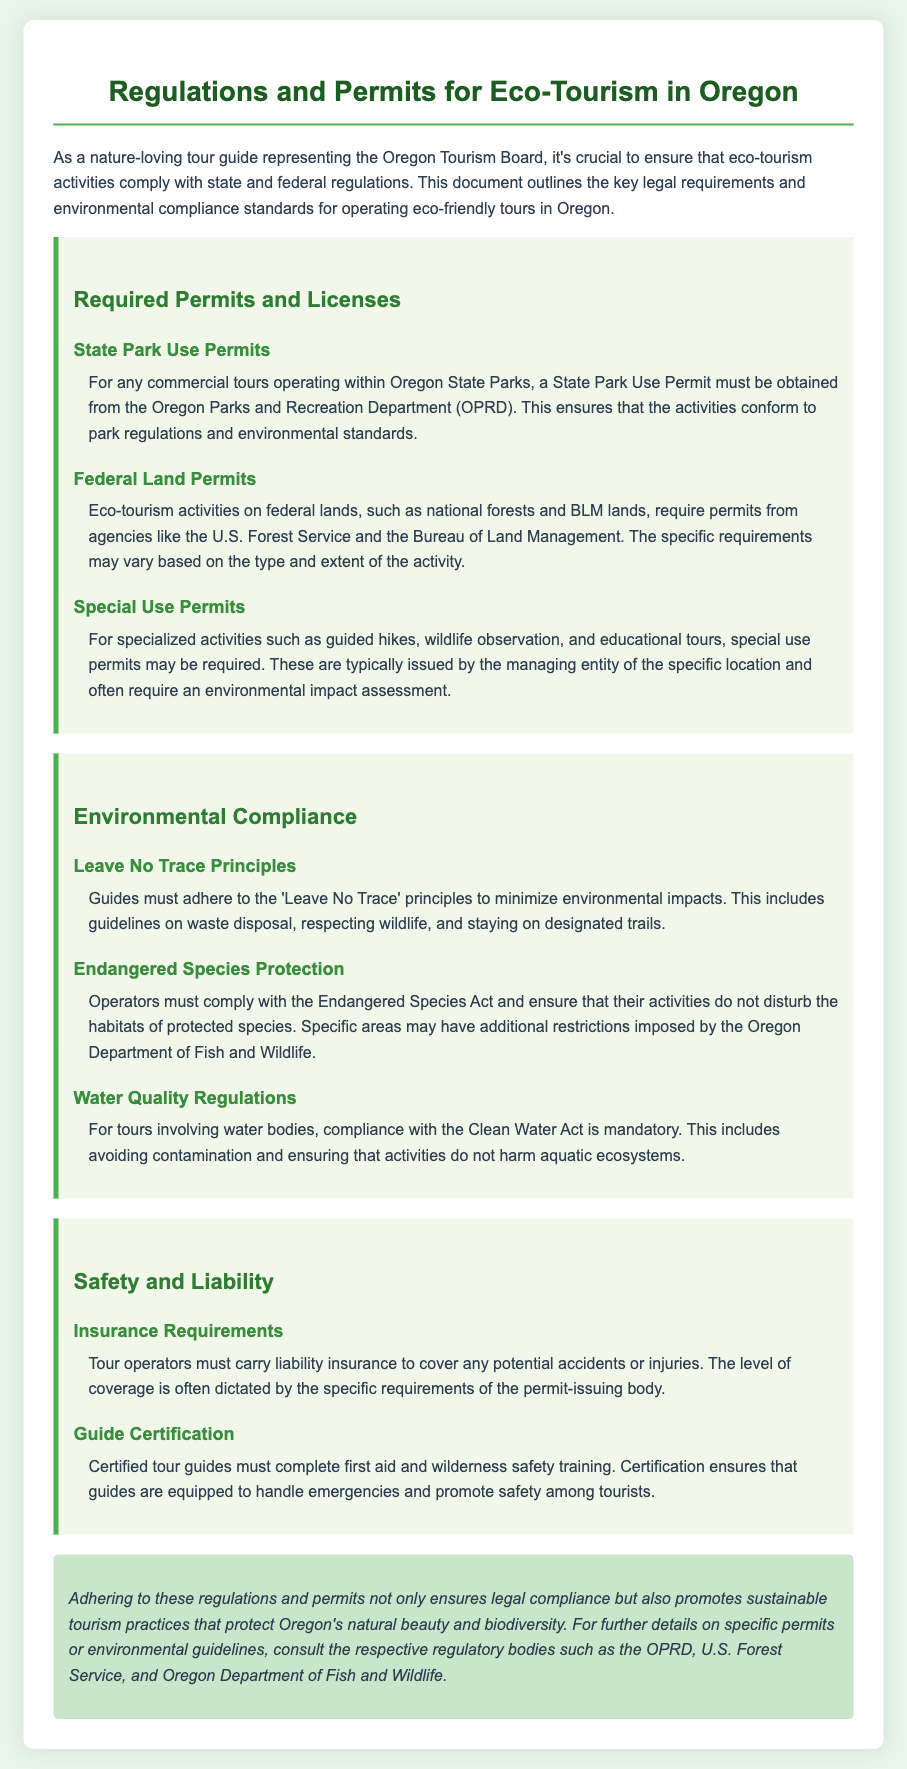What must be obtained for commercial tours in State Parks? The document states that a State Park Use Permit must be obtained from the Oregon Parks and Recreation Department.
Answer: State Park Use Permit What is required for eco-tourism activities on federal lands? The document indicates that eco-tourism activities on federal lands require permits from agencies like the U.S. Forest Service and the Bureau of Land Management.
Answer: Permits from agencies What do tour operators need to ensure regarding endangered species? Operators must comply with the Endangered Species Act and ensure that their activities do not disturb the habitats of protected species.
Answer: Endangered Species Act What must guides adhere to minimize environmental impacts? The document mentions that guides must adhere to the 'Leave No Trace' principles to minimize environmental impacts.
Answer: Leave No Trace principles What type of insurance must tour operators carry? According to the document, tour operators must carry liability insurance to cover any potential accidents or injuries.
Answer: Liability insurance What training must certified tour guides complete? The document states that certified tour guides must complete first aid and wilderness safety training.
Answer: First aid and wilderness safety training 